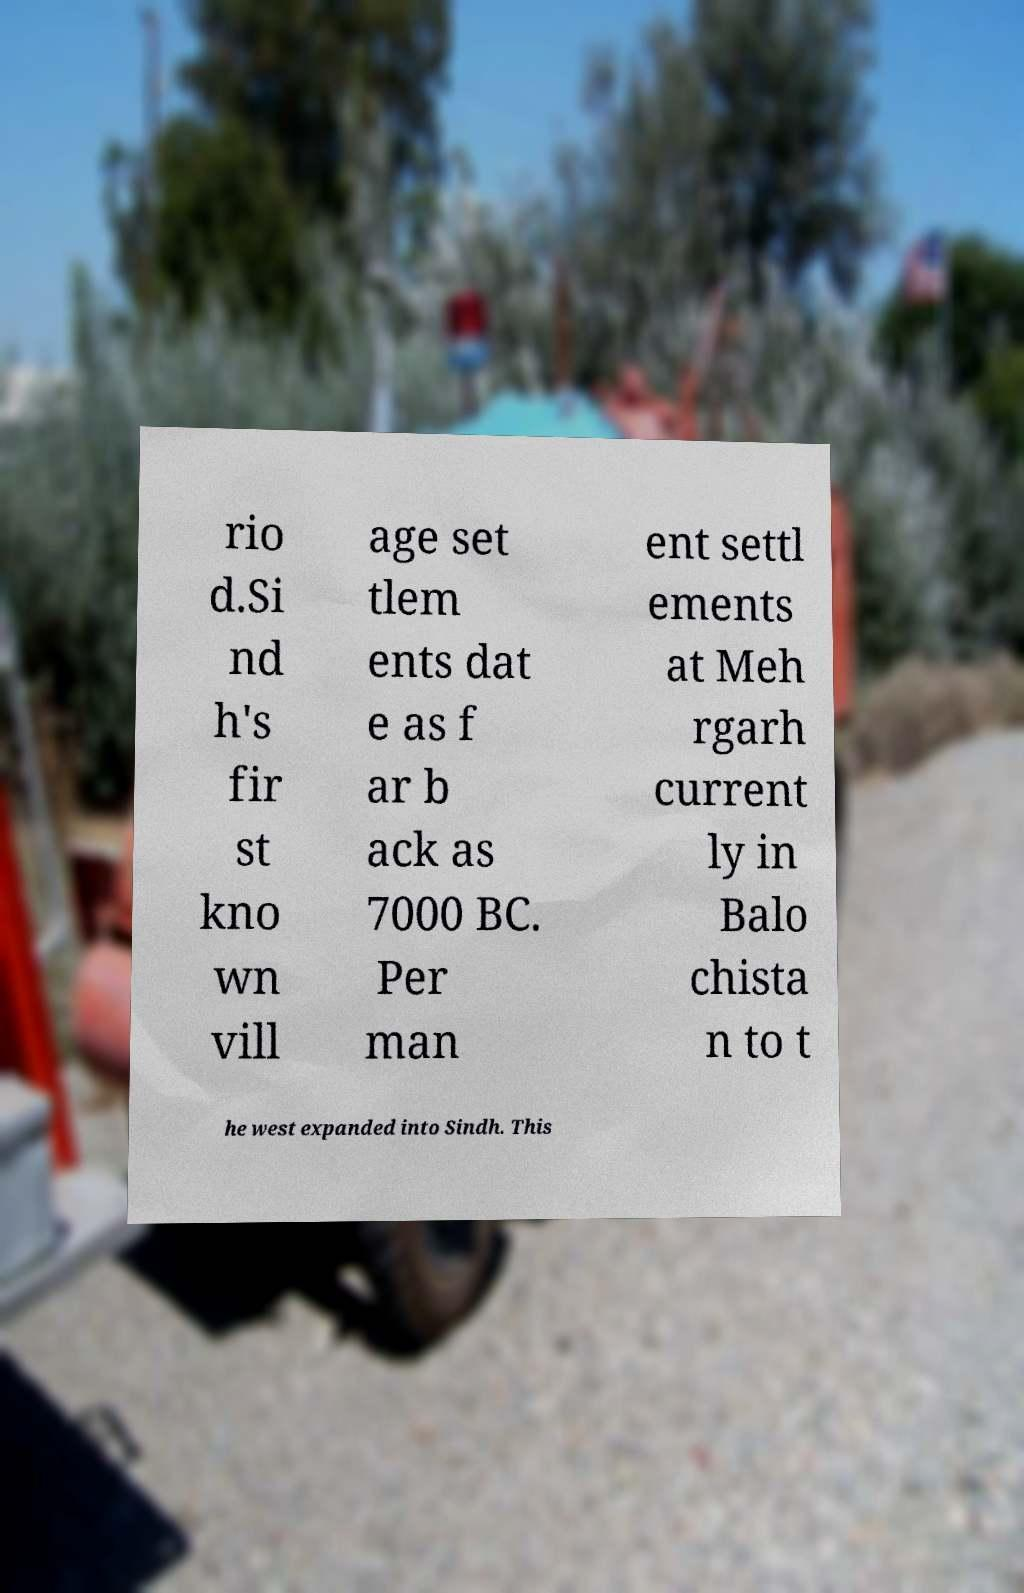Can you accurately transcribe the text from the provided image for me? rio d.Si nd h's fir st kno wn vill age set tlem ents dat e as f ar b ack as 7000 BC. Per man ent settl ements at Meh rgarh current ly in Balo chista n to t he west expanded into Sindh. This 